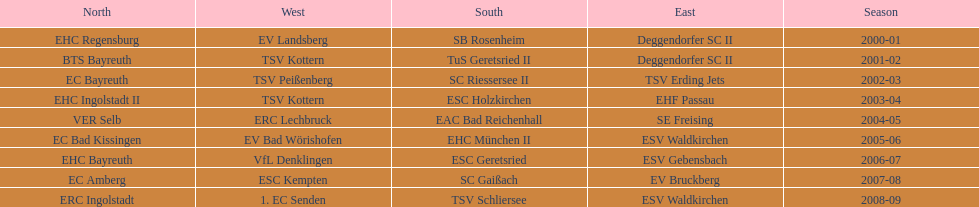How many champions are listend in the north? 9. 